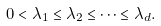Convert formula to latex. <formula><loc_0><loc_0><loc_500><loc_500>0 < \lambda _ { 1 } \leq \lambda _ { 2 } \leq \dots \leq \lambda _ { d } .</formula> 